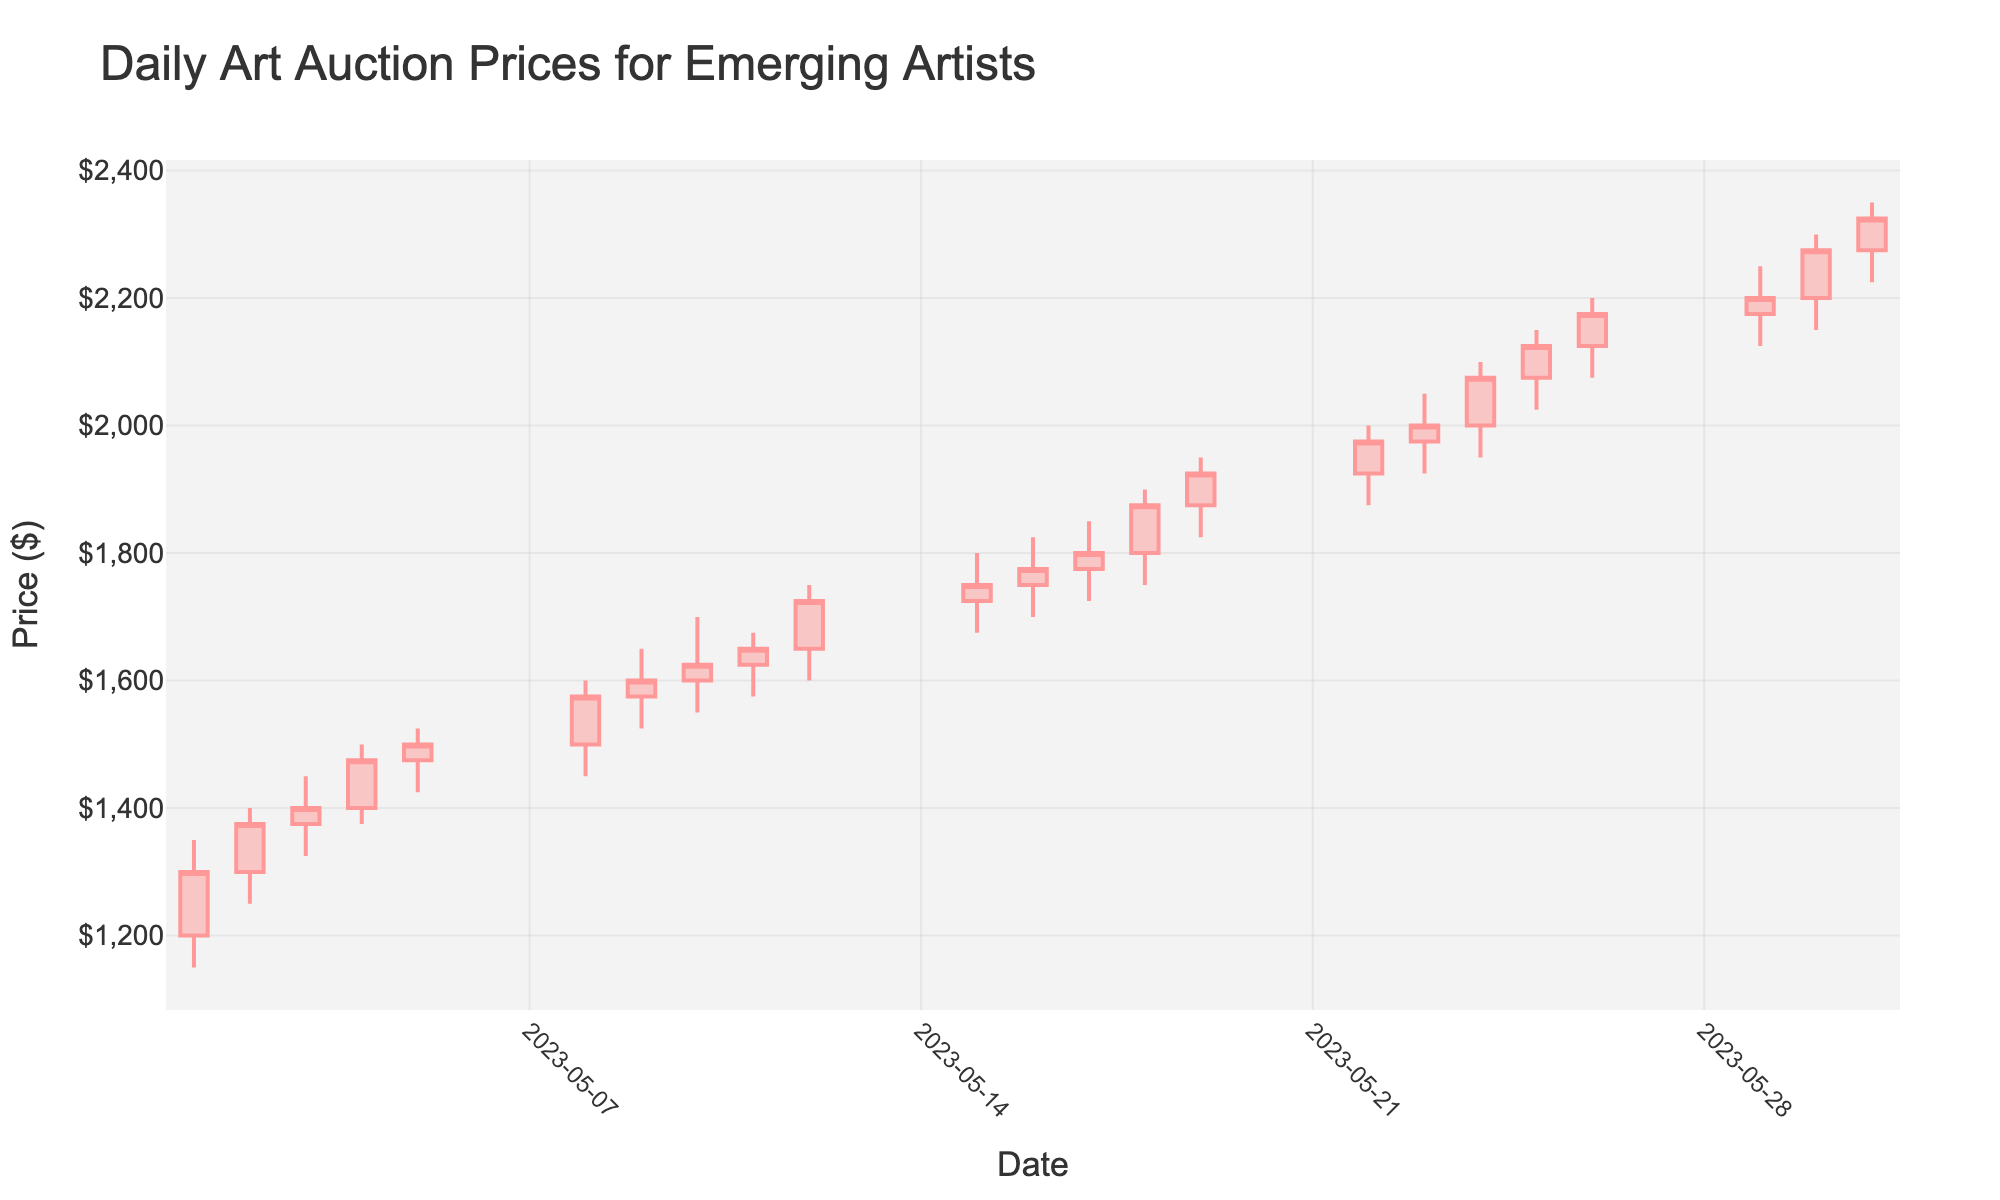what is the highest price reached during the month? To find the highest price, look at the highest "High" value in the OHLC chart. The highest value observed is $2350 on 2023-05-31.
Answer: $2350 On which date did the lowest opening price occur? To determine the lowest opening price, examine the "Open" column. The lowest opening price, $1200, was on 2023-05-01.
Answer: 2023-05-01 Which day had the greatest increase from open to close? To find the greatest increase, we compare the difference between the Open and Close prices for each day. The largest increase is on 2023-05-01, which had an increase of $1300 - $1200 = $100.
Answer: 2023-05-01 What was the opening price on May 15th? Look at the opening price in the OHLC chart for May 15th. The value is $1725.
Answer: $1725 How many days did the closing price exceed $1500? Find the number of days where the closing price is greater than $1500. This occurs on 13 days: 2023-05-08, 2023-05-09, 2023-05-10, 2023-05-11, 2023-05-12, 2023-05-15, 2023-05-16, 2023-05-17, 2023-05-18, 2023-05-19, 2023-05-22, 2023-05-23, and 2023-05-24.
Answer: 13 Which date experienced the highest volatility? Volatility can be measured by the range (High-Low) for each day. The highest range is on 2023-05-31 with a range of $2350 - $2225 = $125.
Answer: 2023-05-31 What is the trend observed in the closing prices from May 1st to May 31st? Observing the closing prices over the month, we see a consistent upward trend from $1300 on May 1st to $2325 on May 31st.
Answer: Upward Trend Between May 5th and May 8th, what was the percentage increase in the closing price? Calculate the percentage increase from May 5th ($1500) to May 8th ($1575) using: [(1575 - 1500) / 1500] * 100 = 5%.
Answer: 5% Which days showed a negative closing value compared to the previous day? To find this, compare each day's closing price with the previous day's. Only May 11th ($1650) compared to May 10th ($1625) shows a negative closing ($1650 < $1625).
Answer: May 11th What was the average closing price during the last week of May? Calculate the average closing price from May 25th to May 31st: (2125 + 2175 + 2200 + 2275 + 2325) / 5 = $2220.
Answer: $2220 